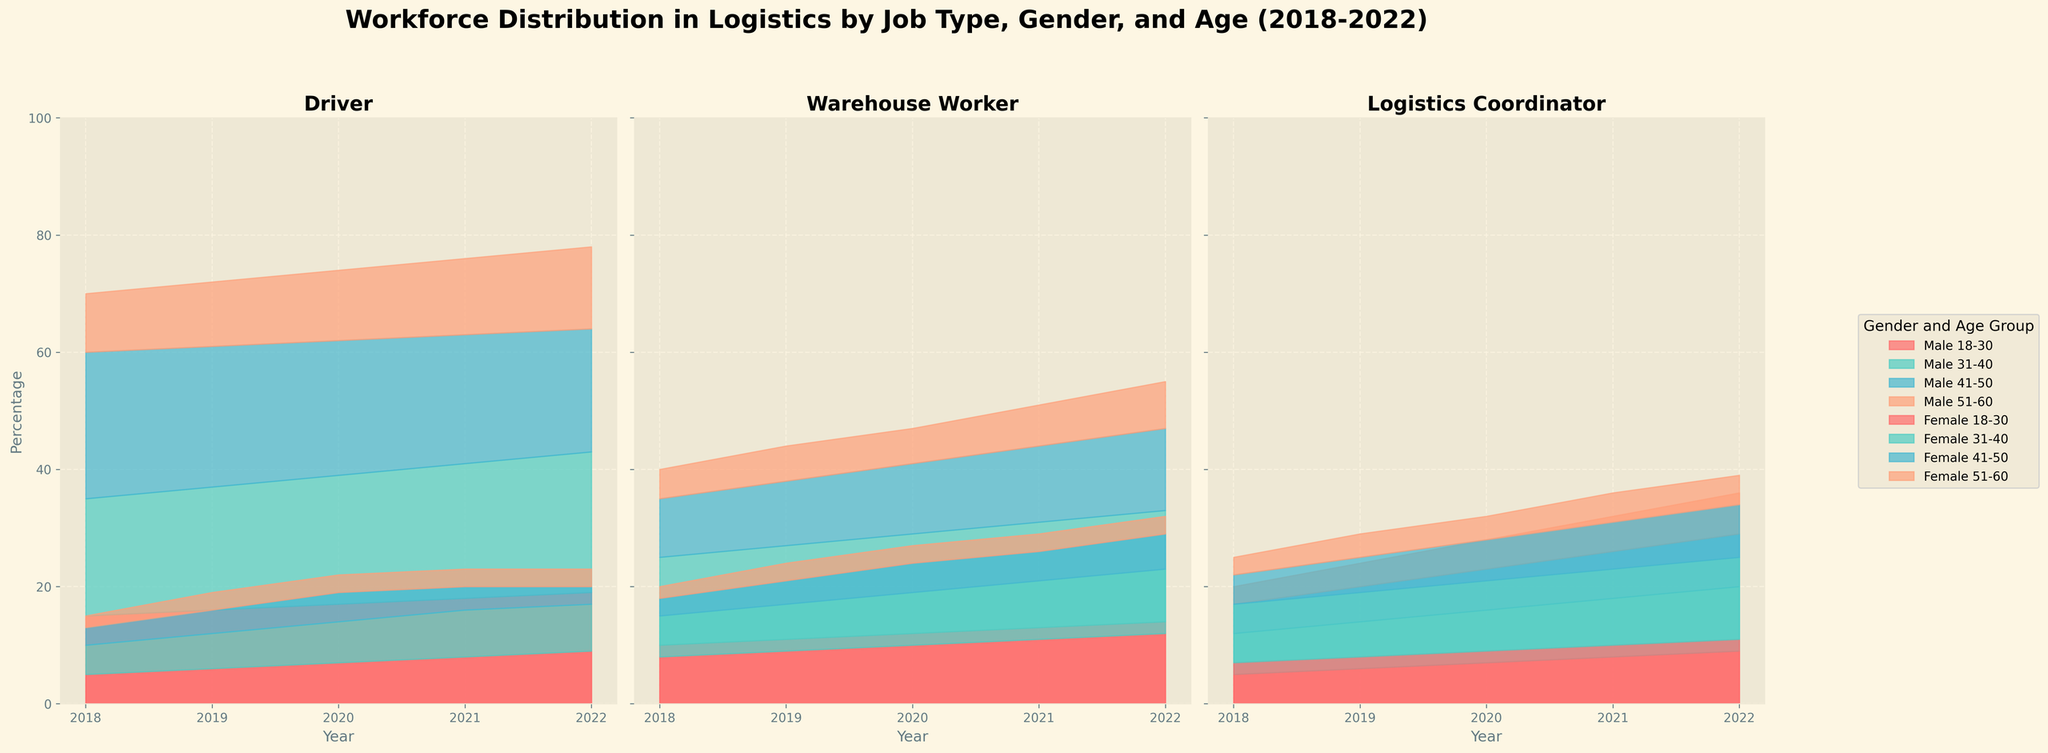What is the title of the figure? The title is displayed prominently at the top of the figure in bold and large font. The title reads "Workforce Distribution in Logistics by Job Type, Gender, and Age (2018-2022)".
Answer: Workforce Distribution in Logistics by Job Type, Gender, and Age (2018-2022) How many job types are represented in the figure? The figure consists of three subplots, each labeled with a different job type. These job types are: "Driver", "Warehouse Worker", and "Logistics Coordinator".
Answer: 3 What is the highest percentage of "Male Drivers" for the "31-40" age group across all years? Inspect the area labeled for "Male 31-40" in the Driver subplot. The highest percentage occurs in the year 2022, where it reaches 24%.
Answer: 24% Between 2018 and 2022, how did the percentage of "Female Warehouse Workers" aged "18-30" change? Examine the area representing "Female 18-30" in the Warehouse Worker subplot. In 2018, it is 8%, and in 2022, it is 12%. To find the change, calculate 12% - 8% = 4%.
Answer: Increased by 4% In 2020, which age group had the smallest percentage of "Female Logistics Coordinators"? Identify the age groups for Female Logistics Coordinators in 2020 in the corresponding subplot. The smallest percentage is represented by "51-60" age group with 4%.
Answer: 51-60 Compare the total percentage of male workforce (sum of all age groups) for "Drivers" in 2018 and 2022. Which year had a higher percentage and by how much? Sum the percentages for all male age groups for Drivers in 2018 (15% + 20% + 25% + 10% = 70%) and in 2022 (19% + 24% + 21% + 14% = 78%). Compare the sums: 78% - 70% = 8%.
Answer: 2022 by 8% What trend is observed for the percentage of "Male Warehouse Workers" aged "18-30" from 2018 to 2022? Examine the area for "Male 18-30" in the Warehouse Worker subplot. Starting at 10% in 2018, it shows a steady increase year by year until reaching 14% in 2022.
Answer: Increasing trend What is the most significant difference in workforce distribution by gender and age for "Logistics Coordinators" in 2022? Compare all gender and age groups for Logistics Coordinators in 2022. The most significant difference is between "Female 31-40" and "Male 51-60", which are 14% and 7% respectively. The difference is 14% - 7% = 7%.
Answer: 7% Which gender and age group had the largest percentage increase for "Drivers" from 2018 to 2022? Compare the percentages for all gender and age groups for Drivers from 2018 to 2022. "Male 18-30" had the largest increase, from 15% in 2018 to 19% in 2022. The increase is 19% - 15% = 4%.
Answer: Male 18-30 